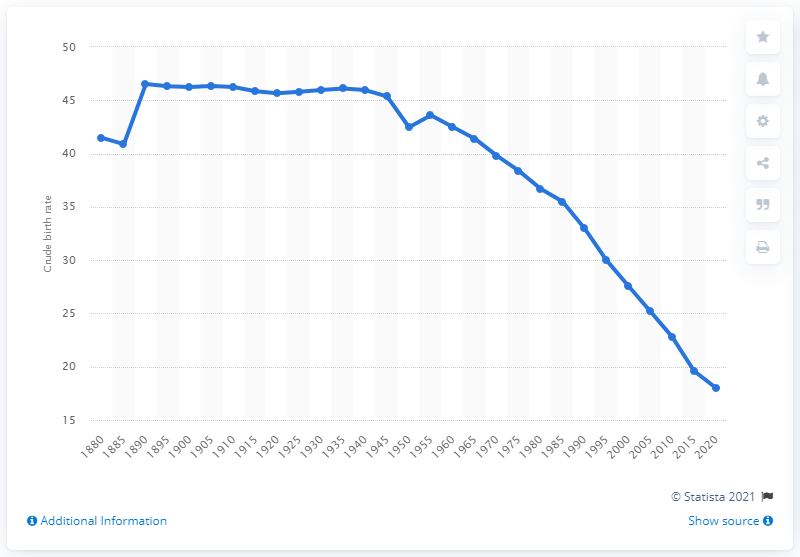Mention a couple of crucial points in this snapshot. In the year 1945, India gained independence from the British Empire. According to projections, India's crude birth rate is expected to reach 18 births per thousand people in 2020. 